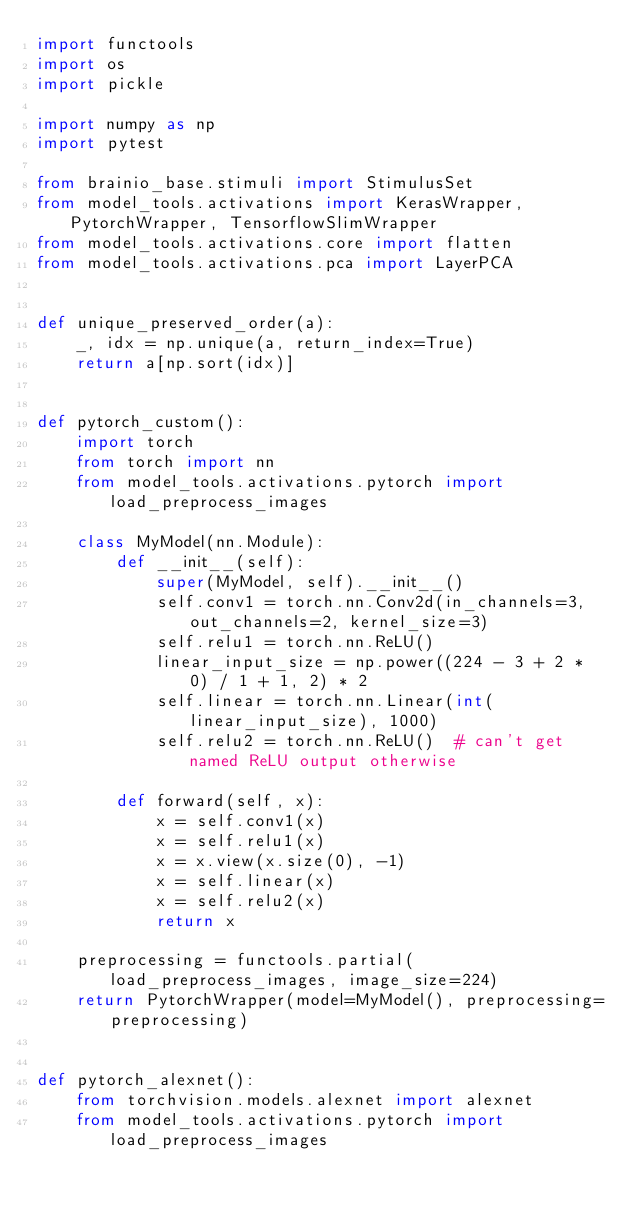<code> <loc_0><loc_0><loc_500><loc_500><_Python_>import functools
import os
import pickle

import numpy as np
import pytest

from brainio_base.stimuli import StimulusSet
from model_tools.activations import KerasWrapper, PytorchWrapper, TensorflowSlimWrapper
from model_tools.activations.core import flatten
from model_tools.activations.pca import LayerPCA


def unique_preserved_order(a):
    _, idx = np.unique(a, return_index=True)
    return a[np.sort(idx)]


def pytorch_custom():
    import torch
    from torch import nn
    from model_tools.activations.pytorch import load_preprocess_images

    class MyModel(nn.Module):
        def __init__(self):
            super(MyModel, self).__init__()
            self.conv1 = torch.nn.Conv2d(in_channels=3, out_channels=2, kernel_size=3)
            self.relu1 = torch.nn.ReLU()
            linear_input_size = np.power((224 - 3 + 2 * 0) / 1 + 1, 2) * 2
            self.linear = torch.nn.Linear(int(linear_input_size), 1000)
            self.relu2 = torch.nn.ReLU()  # can't get named ReLU output otherwise

        def forward(self, x):
            x = self.conv1(x)
            x = self.relu1(x)
            x = x.view(x.size(0), -1)
            x = self.linear(x)
            x = self.relu2(x)
            return x

    preprocessing = functools.partial(load_preprocess_images, image_size=224)
    return PytorchWrapper(model=MyModel(), preprocessing=preprocessing)


def pytorch_alexnet():
    from torchvision.models.alexnet import alexnet
    from model_tools.activations.pytorch import load_preprocess_images
</code> 